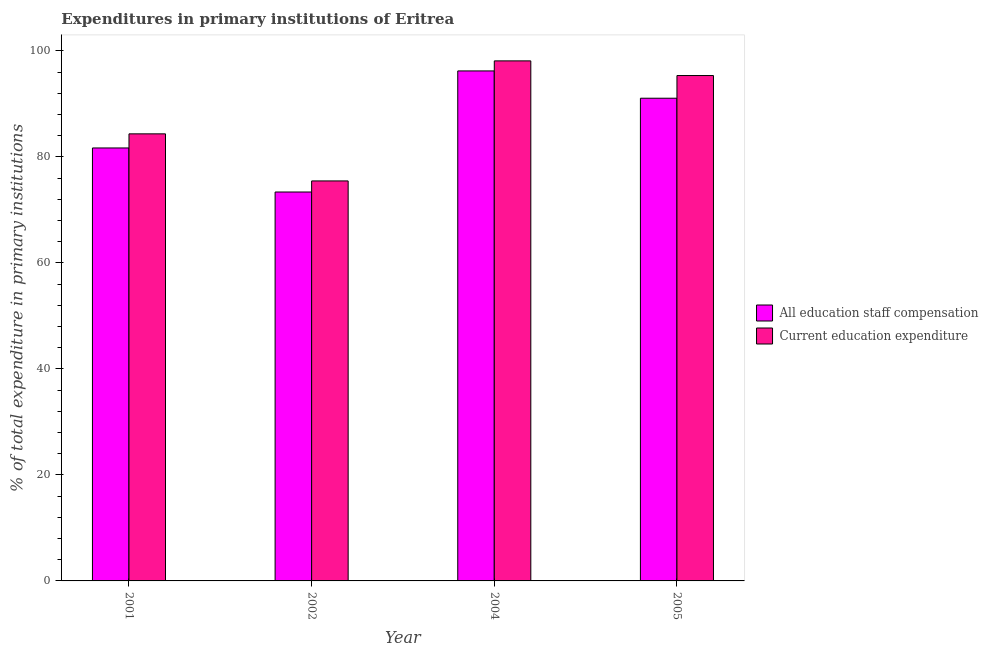How many groups of bars are there?
Keep it short and to the point. 4. Are the number of bars per tick equal to the number of legend labels?
Your answer should be compact. Yes. Are the number of bars on each tick of the X-axis equal?
Make the answer very short. Yes. How many bars are there on the 3rd tick from the right?
Ensure brevity in your answer.  2. What is the label of the 3rd group of bars from the left?
Give a very brief answer. 2004. In how many cases, is the number of bars for a given year not equal to the number of legend labels?
Provide a succinct answer. 0. What is the expenditure in staff compensation in 2004?
Provide a succinct answer. 96.2. Across all years, what is the maximum expenditure in education?
Your answer should be compact. 98.1. Across all years, what is the minimum expenditure in education?
Your answer should be compact. 75.45. In which year was the expenditure in staff compensation maximum?
Provide a succinct answer. 2004. What is the total expenditure in staff compensation in the graph?
Ensure brevity in your answer.  342.29. What is the difference between the expenditure in staff compensation in 2002 and that in 2004?
Make the answer very short. -22.84. What is the difference between the expenditure in education in 2001 and the expenditure in staff compensation in 2002?
Give a very brief answer. 8.88. What is the average expenditure in staff compensation per year?
Your answer should be compact. 85.57. In the year 2001, what is the difference between the expenditure in education and expenditure in staff compensation?
Provide a short and direct response. 0. In how many years, is the expenditure in staff compensation greater than 4 %?
Ensure brevity in your answer.  4. What is the ratio of the expenditure in staff compensation in 2001 to that in 2002?
Offer a terse response. 1.11. Is the expenditure in staff compensation in 2001 less than that in 2002?
Give a very brief answer. No. What is the difference between the highest and the second highest expenditure in staff compensation?
Your answer should be very brief. 5.15. What is the difference between the highest and the lowest expenditure in education?
Your answer should be compact. 22.65. Is the sum of the expenditure in education in 2001 and 2005 greater than the maximum expenditure in staff compensation across all years?
Offer a very short reply. Yes. What does the 2nd bar from the left in 2005 represents?
Your answer should be compact. Current education expenditure. What does the 2nd bar from the right in 2001 represents?
Provide a short and direct response. All education staff compensation. Are all the bars in the graph horizontal?
Provide a succinct answer. No. Does the graph contain grids?
Your response must be concise. No. How many legend labels are there?
Give a very brief answer. 2. What is the title of the graph?
Keep it short and to the point. Expenditures in primary institutions of Eritrea. What is the label or title of the X-axis?
Your answer should be compact. Year. What is the label or title of the Y-axis?
Offer a very short reply. % of total expenditure in primary institutions. What is the % of total expenditure in primary institutions in All education staff compensation in 2001?
Ensure brevity in your answer.  81.67. What is the % of total expenditure in primary institutions in Current education expenditure in 2001?
Your answer should be compact. 84.33. What is the % of total expenditure in primary institutions of All education staff compensation in 2002?
Offer a very short reply. 73.36. What is the % of total expenditure in primary institutions of Current education expenditure in 2002?
Provide a short and direct response. 75.45. What is the % of total expenditure in primary institutions in All education staff compensation in 2004?
Make the answer very short. 96.2. What is the % of total expenditure in primary institutions of Current education expenditure in 2004?
Ensure brevity in your answer.  98.1. What is the % of total expenditure in primary institutions in All education staff compensation in 2005?
Your answer should be very brief. 91.05. What is the % of total expenditure in primary institutions of Current education expenditure in 2005?
Ensure brevity in your answer.  95.33. Across all years, what is the maximum % of total expenditure in primary institutions of All education staff compensation?
Offer a terse response. 96.2. Across all years, what is the maximum % of total expenditure in primary institutions in Current education expenditure?
Give a very brief answer. 98.1. Across all years, what is the minimum % of total expenditure in primary institutions of All education staff compensation?
Provide a succinct answer. 73.36. Across all years, what is the minimum % of total expenditure in primary institutions of Current education expenditure?
Your answer should be very brief. 75.45. What is the total % of total expenditure in primary institutions in All education staff compensation in the graph?
Your answer should be very brief. 342.29. What is the total % of total expenditure in primary institutions in Current education expenditure in the graph?
Ensure brevity in your answer.  353.22. What is the difference between the % of total expenditure in primary institutions in All education staff compensation in 2001 and that in 2002?
Make the answer very short. 8.31. What is the difference between the % of total expenditure in primary institutions of Current education expenditure in 2001 and that in 2002?
Give a very brief answer. 8.88. What is the difference between the % of total expenditure in primary institutions in All education staff compensation in 2001 and that in 2004?
Keep it short and to the point. -14.53. What is the difference between the % of total expenditure in primary institutions in Current education expenditure in 2001 and that in 2004?
Offer a terse response. -13.76. What is the difference between the % of total expenditure in primary institutions in All education staff compensation in 2001 and that in 2005?
Your response must be concise. -9.38. What is the difference between the % of total expenditure in primary institutions in Current education expenditure in 2001 and that in 2005?
Ensure brevity in your answer.  -11. What is the difference between the % of total expenditure in primary institutions in All education staff compensation in 2002 and that in 2004?
Provide a short and direct response. -22.84. What is the difference between the % of total expenditure in primary institutions in Current education expenditure in 2002 and that in 2004?
Your response must be concise. -22.65. What is the difference between the % of total expenditure in primary institutions in All education staff compensation in 2002 and that in 2005?
Offer a very short reply. -17.69. What is the difference between the % of total expenditure in primary institutions in Current education expenditure in 2002 and that in 2005?
Make the answer very short. -19.88. What is the difference between the % of total expenditure in primary institutions of All education staff compensation in 2004 and that in 2005?
Make the answer very short. 5.15. What is the difference between the % of total expenditure in primary institutions in Current education expenditure in 2004 and that in 2005?
Your answer should be compact. 2.77. What is the difference between the % of total expenditure in primary institutions in All education staff compensation in 2001 and the % of total expenditure in primary institutions in Current education expenditure in 2002?
Provide a succinct answer. 6.22. What is the difference between the % of total expenditure in primary institutions of All education staff compensation in 2001 and the % of total expenditure in primary institutions of Current education expenditure in 2004?
Provide a short and direct response. -16.43. What is the difference between the % of total expenditure in primary institutions in All education staff compensation in 2001 and the % of total expenditure in primary institutions in Current education expenditure in 2005?
Provide a succinct answer. -13.66. What is the difference between the % of total expenditure in primary institutions in All education staff compensation in 2002 and the % of total expenditure in primary institutions in Current education expenditure in 2004?
Ensure brevity in your answer.  -24.74. What is the difference between the % of total expenditure in primary institutions in All education staff compensation in 2002 and the % of total expenditure in primary institutions in Current education expenditure in 2005?
Offer a terse response. -21.97. What is the difference between the % of total expenditure in primary institutions in All education staff compensation in 2004 and the % of total expenditure in primary institutions in Current education expenditure in 2005?
Offer a very short reply. 0.87. What is the average % of total expenditure in primary institutions in All education staff compensation per year?
Provide a short and direct response. 85.57. What is the average % of total expenditure in primary institutions of Current education expenditure per year?
Your response must be concise. 88.3. In the year 2001, what is the difference between the % of total expenditure in primary institutions of All education staff compensation and % of total expenditure in primary institutions of Current education expenditure?
Ensure brevity in your answer.  -2.66. In the year 2002, what is the difference between the % of total expenditure in primary institutions in All education staff compensation and % of total expenditure in primary institutions in Current education expenditure?
Ensure brevity in your answer.  -2.09. In the year 2004, what is the difference between the % of total expenditure in primary institutions in All education staff compensation and % of total expenditure in primary institutions in Current education expenditure?
Your answer should be compact. -1.9. In the year 2005, what is the difference between the % of total expenditure in primary institutions of All education staff compensation and % of total expenditure in primary institutions of Current education expenditure?
Make the answer very short. -4.28. What is the ratio of the % of total expenditure in primary institutions of All education staff compensation in 2001 to that in 2002?
Give a very brief answer. 1.11. What is the ratio of the % of total expenditure in primary institutions in Current education expenditure in 2001 to that in 2002?
Make the answer very short. 1.12. What is the ratio of the % of total expenditure in primary institutions in All education staff compensation in 2001 to that in 2004?
Provide a short and direct response. 0.85. What is the ratio of the % of total expenditure in primary institutions of Current education expenditure in 2001 to that in 2004?
Your answer should be very brief. 0.86. What is the ratio of the % of total expenditure in primary institutions in All education staff compensation in 2001 to that in 2005?
Ensure brevity in your answer.  0.9. What is the ratio of the % of total expenditure in primary institutions of Current education expenditure in 2001 to that in 2005?
Offer a very short reply. 0.88. What is the ratio of the % of total expenditure in primary institutions of All education staff compensation in 2002 to that in 2004?
Offer a terse response. 0.76. What is the ratio of the % of total expenditure in primary institutions in Current education expenditure in 2002 to that in 2004?
Provide a short and direct response. 0.77. What is the ratio of the % of total expenditure in primary institutions of All education staff compensation in 2002 to that in 2005?
Your answer should be very brief. 0.81. What is the ratio of the % of total expenditure in primary institutions in Current education expenditure in 2002 to that in 2005?
Provide a succinct answer. 0.79. What is the ratio of the % of total expenditure in primary institutions of All education staff compensation in 2004 to that in 2005?
Your answer should be compact. 1.06. What is the ratio of the % of total expenditure in primary institutions in Current education expenditure in 2004 to that in 2005?
Offer a terse response. 1.03. What is the difference between the highest and the second highest % of total expenditure in primary institutions in All education staff compensation?
Keep it short and to the point. 5.15. What is the difference between the highest and the second highest % of total expenditure in primary institutions in Current education expenditure?
Offer a very short reply. 2.77. What is the difference between the highest and the lowest % of total expenditure in primary institutions of All education staff compensation?
Provide a short and direct response. 22.84. What is the difference between the highest and the lowest % of total expenditure in primary institutions of Current education expenditure?
Ensure brevity in your answer.  22.65. 